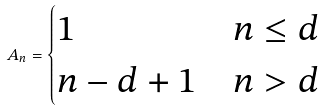Convert formula to latex. <formula><loc_0><loc_0><loc_500><loc_500>A _ { n } = \begin{cases} 1 & n \leq d \\ n - d + 1 & n > d \end{cases}</formula> 